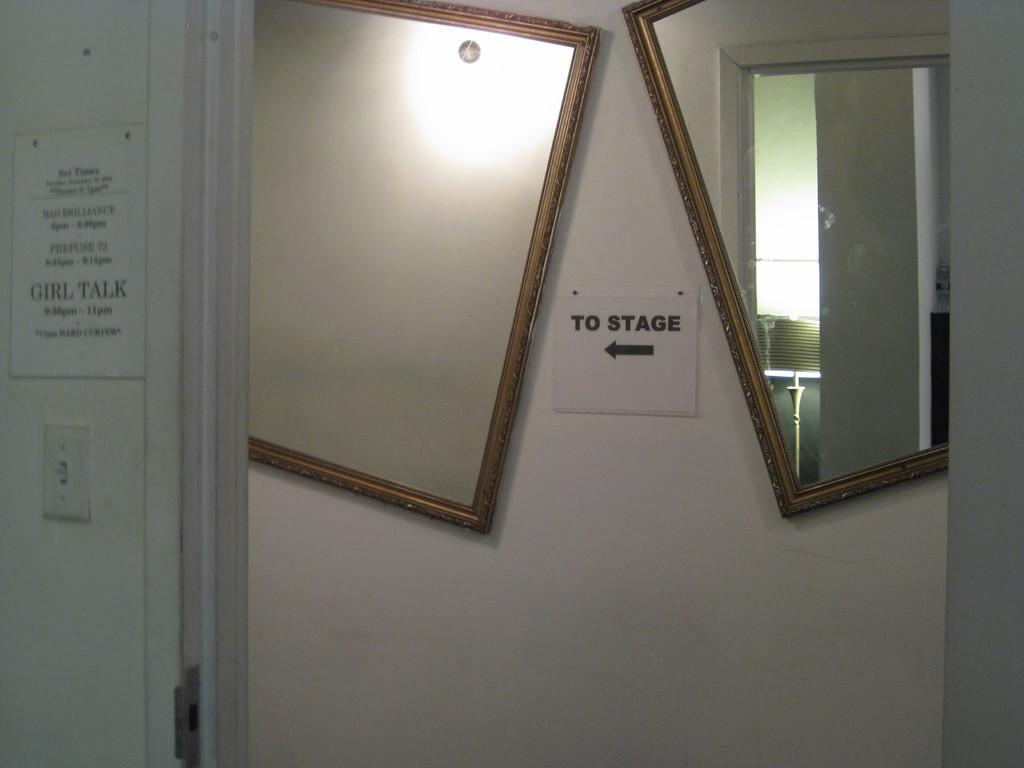Please provide a concise description of this image. There are 2 mirrors on the wall. There is a note in the center. At the left there is a switch and a note. 